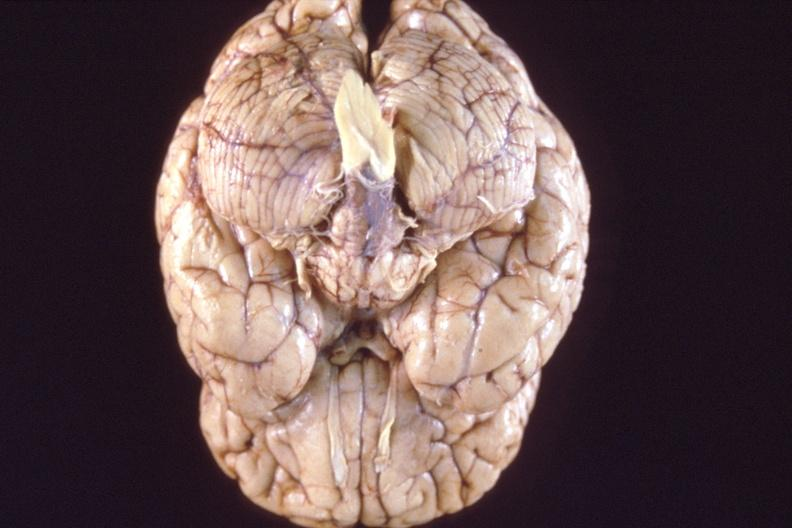does abdomen show brain, breast cancer metastasis to meninges?
Answer the question using a single word or phrase. No 